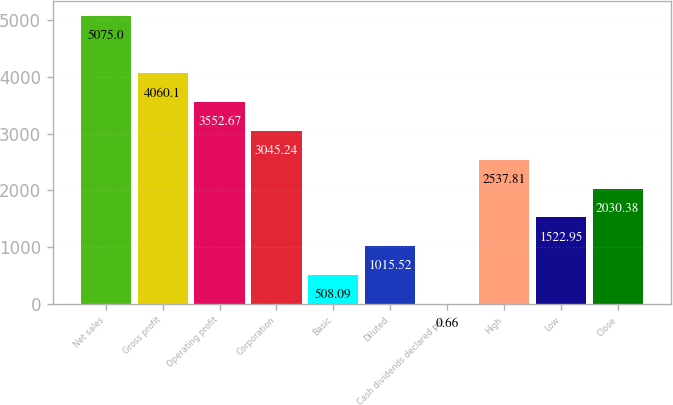<chart> <loc_0><loc_0><loc_500><loc_500><bar_chart><fcel>Net sales<fcel>Gross profit<fcel>Operating profit<fcel>Corporation<fcel>Basic<fcel>Diluted<fcel>Cash dividends declared per<fcel>High<fcel>Low<fcel>Close<nl><fcel>5075<fcel>4060.1<fcel>3552.67<fcel>3045.24<fcel>508.09<fcel>1015.52<fcel>0.66<fcel>2537.81<fcel>1522.95<fcel>2030.38<nl></chart> 